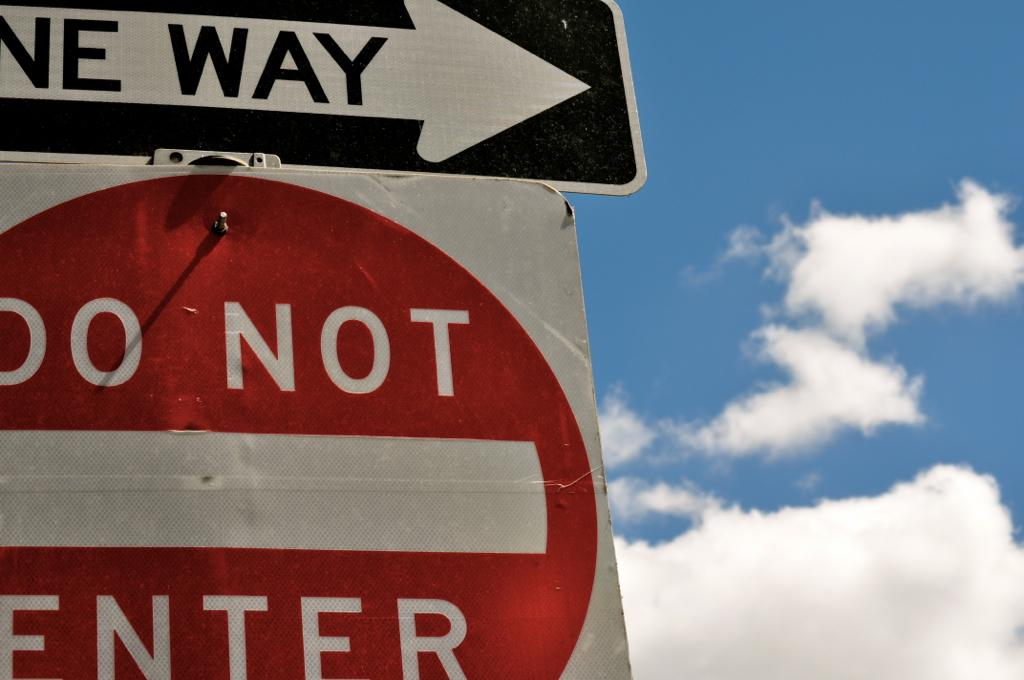<image>
Summarize the visual content of the image. a do not enter sign next to a one way sign 